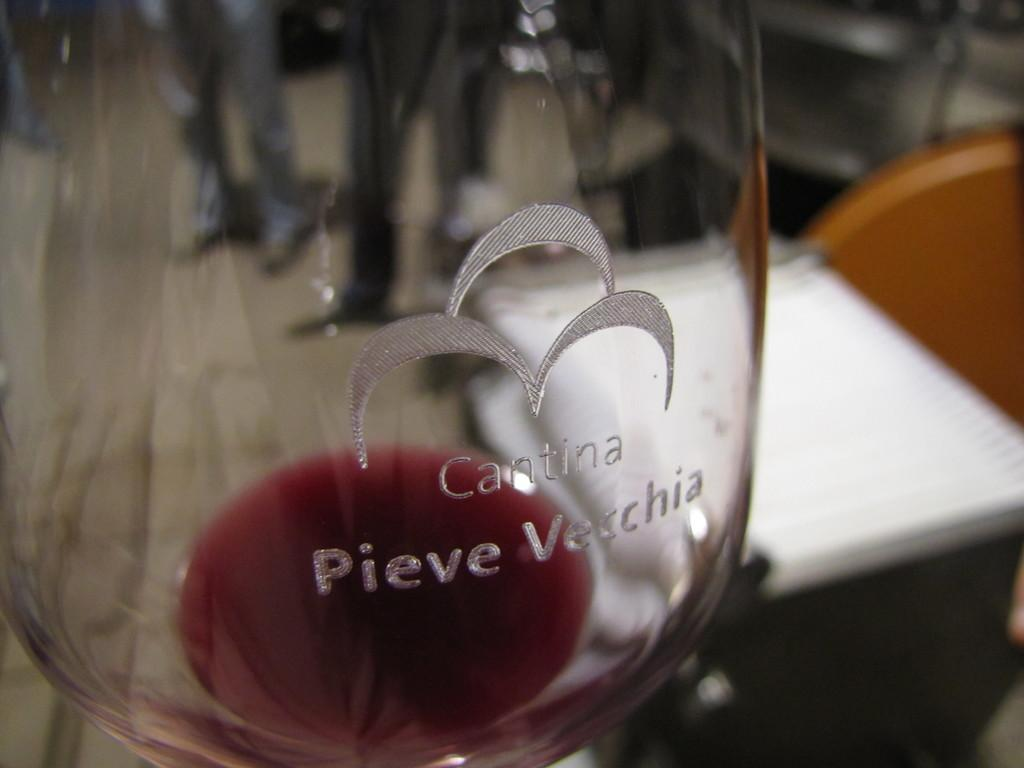<image>
Share a concise interpretation of the image provided. A Cantina wine glass is almost empty with some wine left at the bottom. 